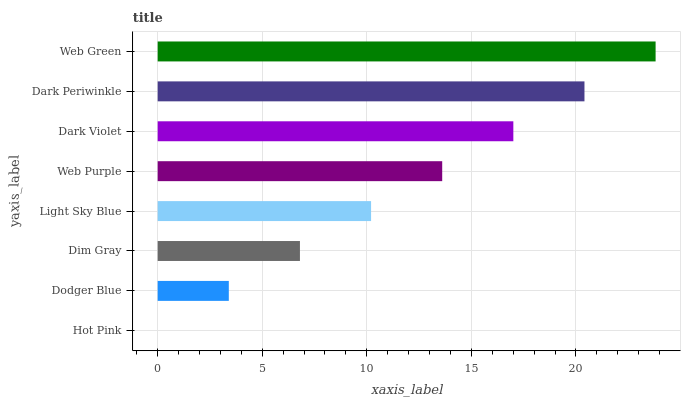Is Hot Pink the minimum?
Answer yes or no. Yes. Is Web Green the maximum?
Answer yes or no. Yes. Is Dodger Blue the minimum?
Answer yes or no. No. Is Dodger Blue the maximum?
Answer yes or no. No. Is Dodger Blue greater than Hot Pink?
Answer yes or no. Yes. Is Hot Pink less than Dodger Blue?
Answer yes or no. Yes. Is Hot Pink greater than Dodger Blue?
Answer yes or no. No. Is Dodger Blue less than Hot Pink?
Answer yes or no. No. Is Web Purple the high median?
Answer yes or no. Yes. Is Light Sky Blue the low median?
Answer yes or no. Yes. Is Dodger Blue the high median?
Answer yes or no. No. Is Dodger Blue the low median?
Answer yes or no. No. 